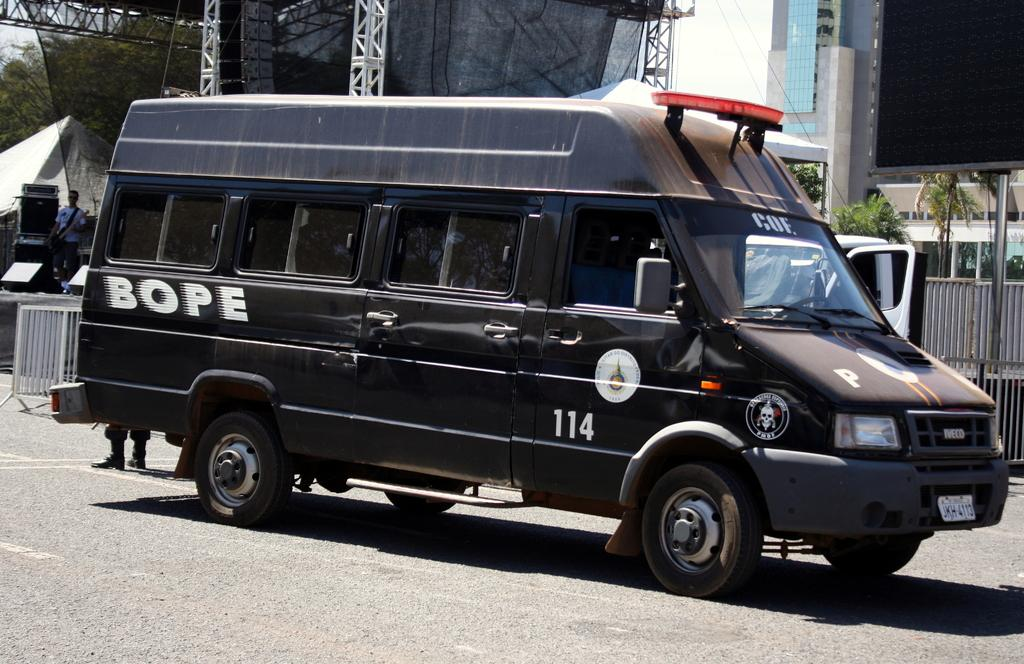<image>
Share a concise interpretation of the image provided. A black armoured van with the word "Bope" written on the side in white 